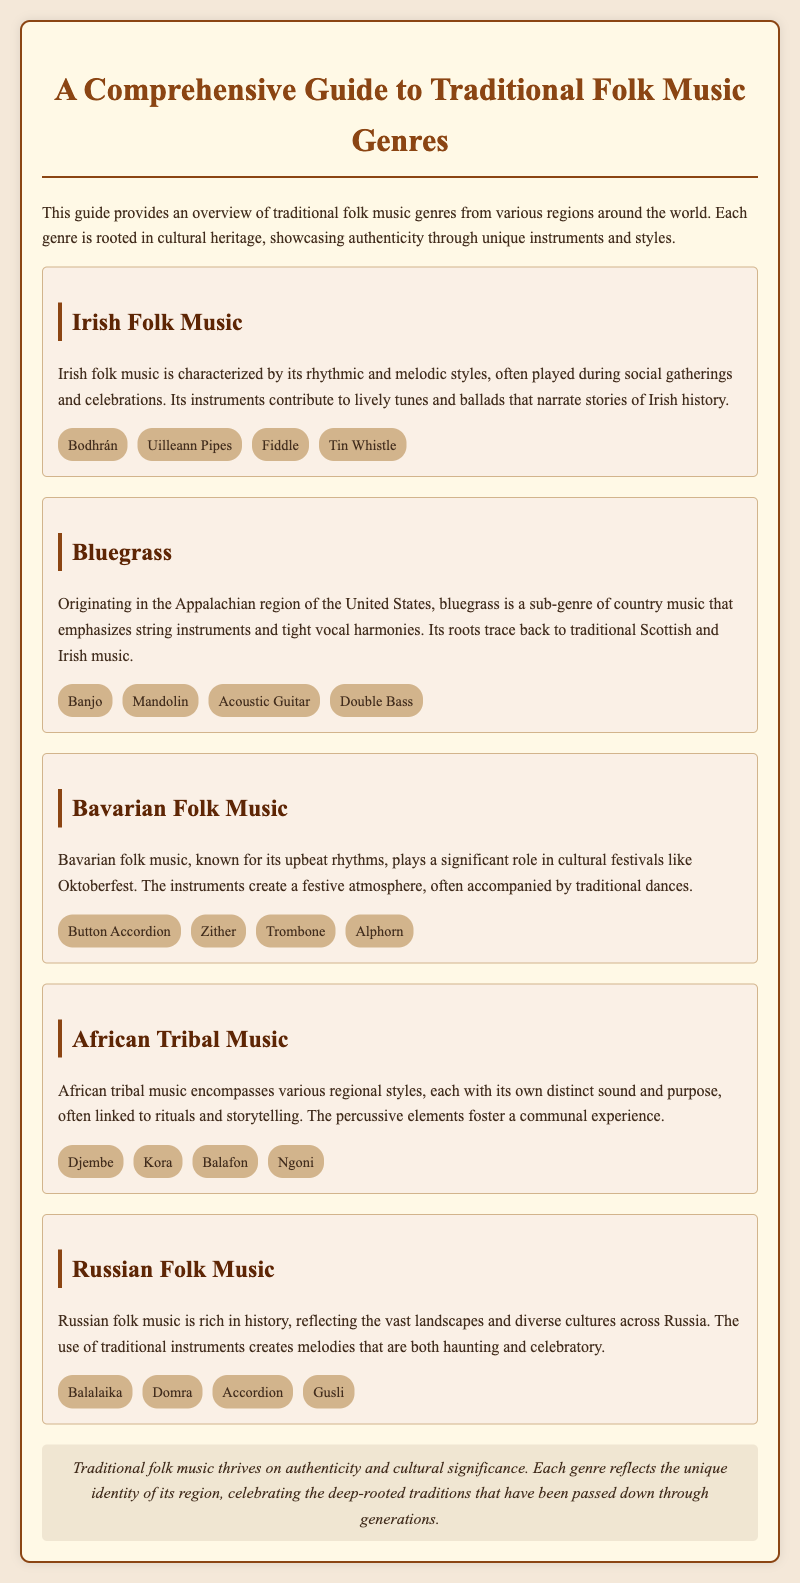What genre is characterized by the Bodhrán? The Bodhrán is an instrument associated with Irish folk music, which is explicitly mentioned in the document.
Answer: Irish Folk Music How many instruments are listed for Bluegrass? The document lists four instruments specifically for Bluegrass music.
Answer: Four Which folk music is linked to Oktoberfest? The document states that Bavarian folk music plays a significant role in cultural festivals like Oktoberfest.
Answer: Bavarian Folk Music What instrument is used in Russian Folk Music that is also a type of string instrument? The Balalaika is explicitly mentioned as a traditional instrument in Russian folk music within the document.
Answer: Balalaika What common aspect is emphasized across all traditional folk music genres mentioned? The document concludes with the point that all genres reflect authenticity and cultural significance.
Answer: Authenticity How many genres of traditional folk music are described in the document? The document describes a total of five distinct genres of traditional folk music.
Answer: Five What aspect of African Tribal Music is highlighted? The document emphasizes the communal experience fostered by the percussive elements in African tribal music.
Answer: Communal experience Which instrument is unique to Irish Folk Music from the list provided? The Uilleann Pipes are specifically listed as an instrument unique to Irish folk music.
Answer: Uilleann Pipes What type of music emphasizes tight vocal harmonies? The document states that Bluegrass emphasizes tight vocal harmonies in its description.
Answer: Bluegrass 